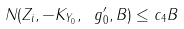Convert formula to latex. <formula><loc_0><loc_0><loc_500><loc_500>N ( Z _ { i } , - K _ { Y _ { 0 } } , \ g _ { 0 } ^ { \prime } , B ) \leq c _ { 4 } B</formula> 